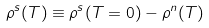Convert formula to latex. <formula><loc_0><loc_0><loc_500><loc_500>\rho ^ { s } ( T ) \equiv \rho ^ { s } ( T = 0 ) - \rho ^ { n } ( T )</formula> 